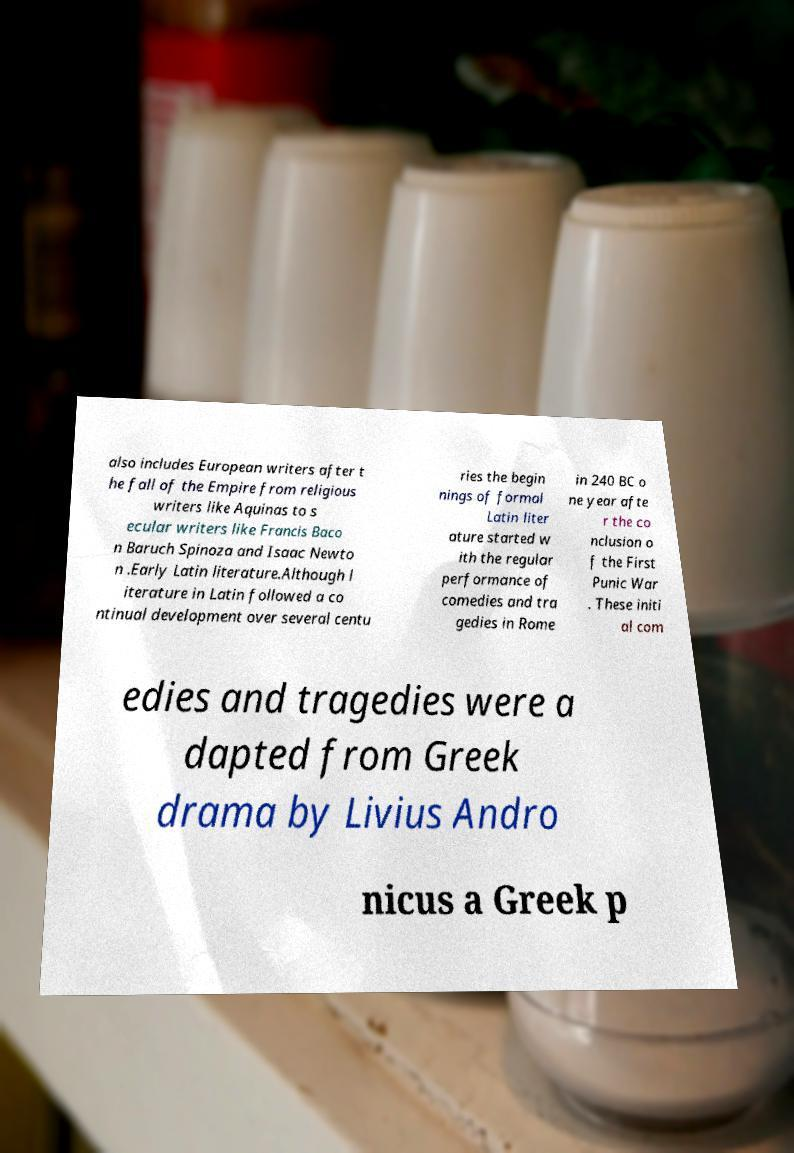There's text embedded in this image that I need extracted. Can you transcribe it verbatim? also includes European writers after t he fall of the Empire from religious writers like Aquinas to s ecular writers like Francis Baco n Baruch Spinoza and Isaac Newto n .Early Latin literature.Although l iterature in Latin followed a co ntinual development over several centu ries the begin nings of formal Latin liter ature started w ith the regular performance of comedies and tra gedies in Rome in 240 BC o ne year afte r the co nclusion o f the First Punic War . These initi al com edies and tragedies were a dapted from Greek drama by Livius Andro nicus a Greek p 